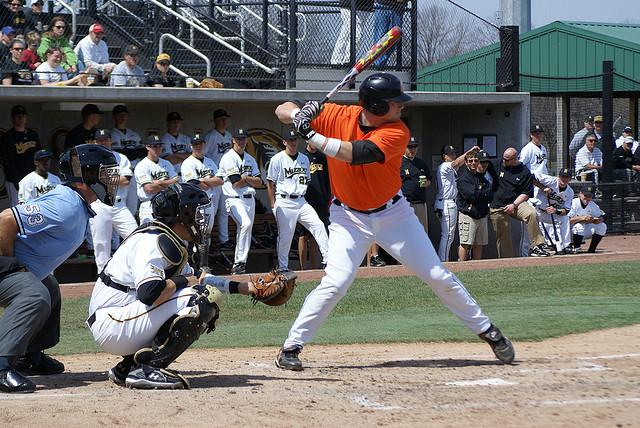What is the brown object in the squatting man's hand? catchers mitt 